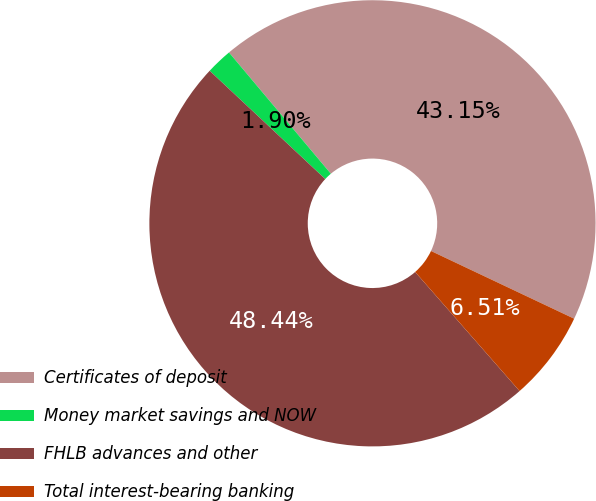<chart> <loc_0><loc_0><loc_500><loc_500><pie_chart><fcel>Certificates of deposit<fcel>Money market savings and NOW<fcel>FHLB advances and other<fcel>Total interest-bearing banking<nl><fcel>43.15%<fcel>1.9%<fcel>48.44%<fcel>6.51%<nl></chart> 